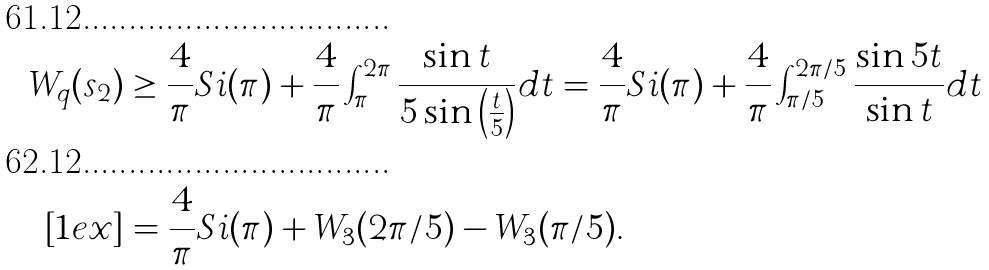Convert formula to latex. <formula><loc_0><loc_0><loc_500><loc_500>W _ { q } ( s _ { 2 } ) & \geq \frac { 4 } { \pi } S i ( \pi ) + \frac { 4 } { \pi } \int _ { \pi } ^ { 2 \pi } \frac { \sin t } { 5 \sin \left ( \frac { t } { 5 } \right ) } d t = \frac { 4 } { \pi } S i ( \pi ) + \frac { 4 } { \pi } \int _ { \pi / 5 } ^ { 2 \pi / 5 } \frac { \sin 5 t } { \sin t } d t \\ [ 1 e x ] & = \frac { 4 } { \pi } S i ( \pi ) + W _ { 3 } ( 2 \pi / 5 ) - W _ { 3 } ( \pi / 5 ) .</formula> 